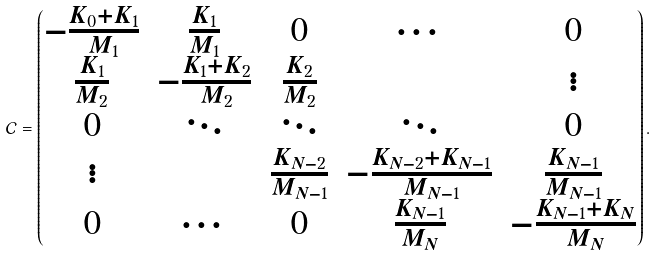Convert formula to latex. <formula><loc_0><loc_0><loc_500><loc_500>\mathcal { C } = \begin{pmatrix} - \frac { K _ { 0 } + K _ { 1 } } { M _ { 1 } } & \frac { K _ { 1 } } { M _ { 1 } } & 0 & \cdots & 0 \\ \frac { K _ { 1 } } { M _ { 2 } } & - \frac { K _ { 1 } + K _ { 2 } } { M _ { 2 } } & \frac { K _ { 2 } } { M _ { 2 } } & & \vdots \\ 0 & \ddots & \ddots & \ddots & 0 \\ \vdots & & \frac { K _ { N - 2 } } { M _ { N - 1 } } & - \frac { K _ { N - 2 } + K _ { N - 1 } } { M _ { N - 1 } } & \frac { K _ { N - 1 } } { M _ { N - 1 } } \\ 0 & \cdots & 0 & \frac { K _ { N - 1 } } { M _ { N } } & - \frac { K _ { N - 1 } + K _ { N } } { M _ { N } } \end{pmatrix} .</formula> 